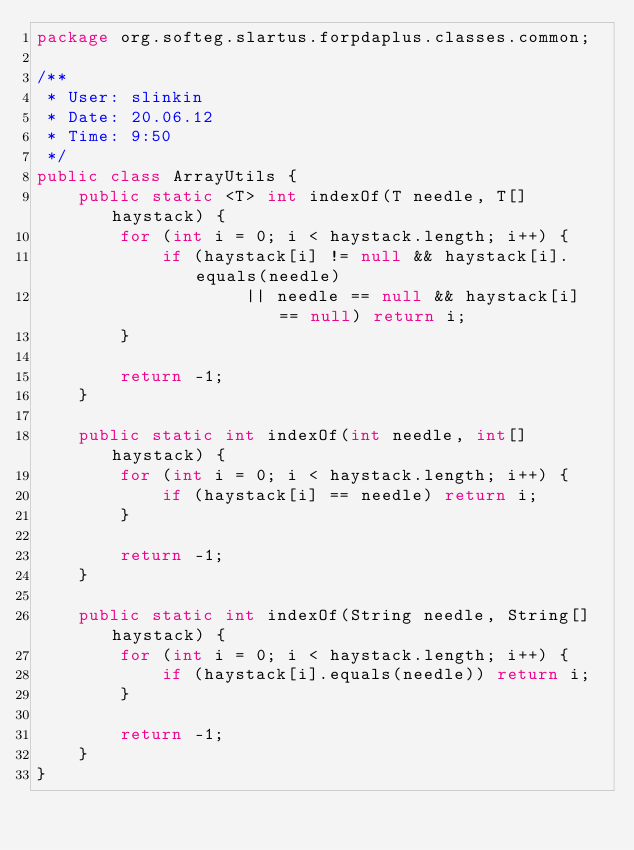Convert code to text. <code><loc_0><loc_0><loc_500><loc_500><_Java_>package org.softeg.slartus.forpdaplus.classes.common;

/**
 * User: slinkin
 * Date: 20.06.12
 * Time: 9:50
 */
public class ArrayUtils {
    public static <T> int indexOf(T needle, T[] haystack) {
        for (int i = 0; i < haystack.length; i++) {
            if (haystack[i] != null && haystack[i].equals(needle)
                    || needle == null && haystack[i] == null) return i;
        }

        return -1;
    }

    public static int indexOf(int needle, int[] haystack) {
        for (int i = 0; i < haystack.length; i++) {
            if (haystack[i] == needle) return i;
        }

        return -1;
    }

    public static int indexOf(String needle, String[] haystack) {
        for (int i = 0; i < haystack.length; i++) {
            if (haystack[i].equals(needle)) return i;
        }

        return -1;
    }
}
</code> 